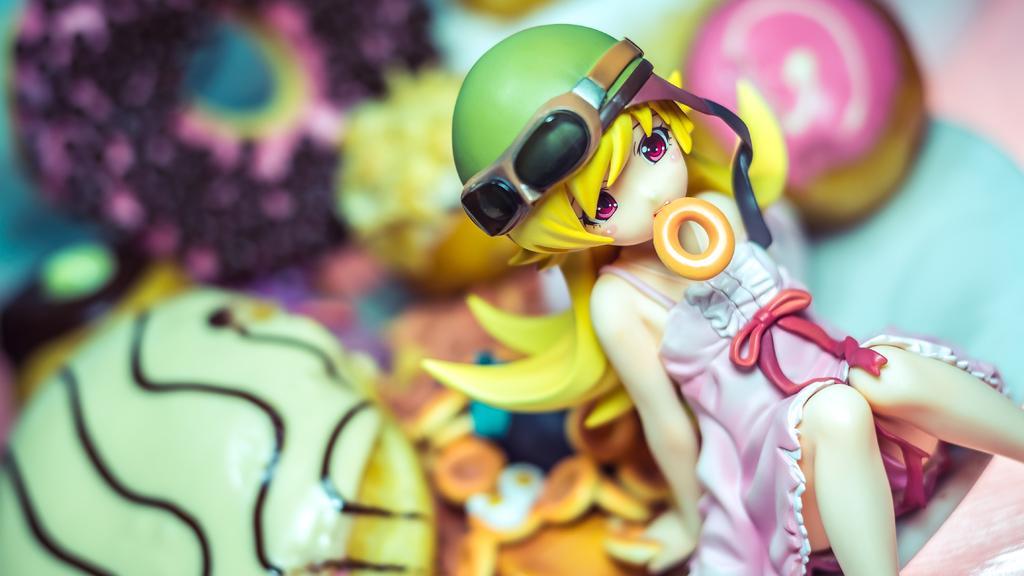Describe this image in one or two sentences. In the picture there is a doll and the background of the doll is blur. 